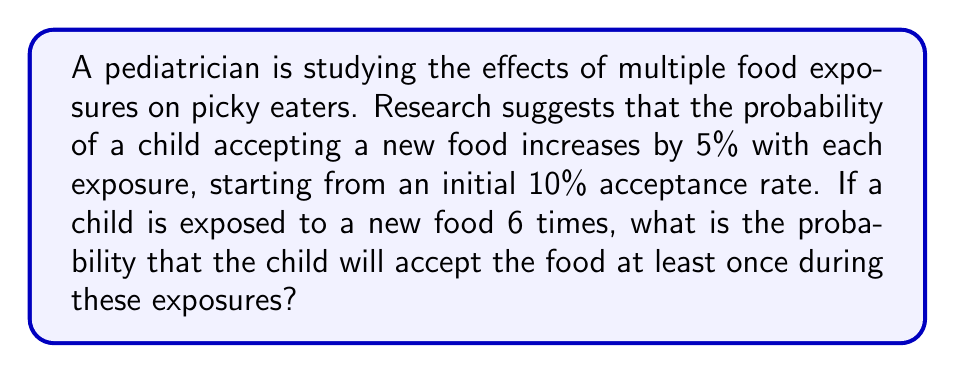Help me with this question. Let's approach this step-by-step:

1) First, let's calculate the probability of accepting the food for each exposure:
   1st exposure: 10%
   2nd exposure: 15%
   3rd exposure: 20%
   4th exposure: 25%
   5th exposure: 30%
   6th exposure: 35%

2) To find the probability of accepting the food at least once, it's easier to calculate the probability of not accepting the food in any of the 6 exposures and then subtract this from 1.

3) The probability of not accepting the food in each exposure:
   1st exposure: 90% = 0.90
   2nd exposure: 85% = 0.85
   3rd exposure: 80% = 0.80
   4th exposure: 75% = 0.75
   5th exposure: 70% = 0.70
   6th exposure: 65% = 0.65

4) The probability of not accepting the food in all 6 exposures is the product of these probabilities:

   $$ P(\text{never accepting}) = 0.90 \times 0.85 \times 0.80 \times 0.75 \times 0.70 \times 0.65 $$

5) Calculate this:
   $$ P(\text{never accepting}) = 0.1819 $$

6) Therefore, the probability of accepting the food at least once is:

   $$ P(\text{accepting at least once}) = 1 - P(\text{never accepting}) = 1 - 0.1819 = 0.8181 $$

7) Convert to a percentage:
   $$ 0.8181 \times 100\% = 81.81\% $$
Answer: 81.81% 